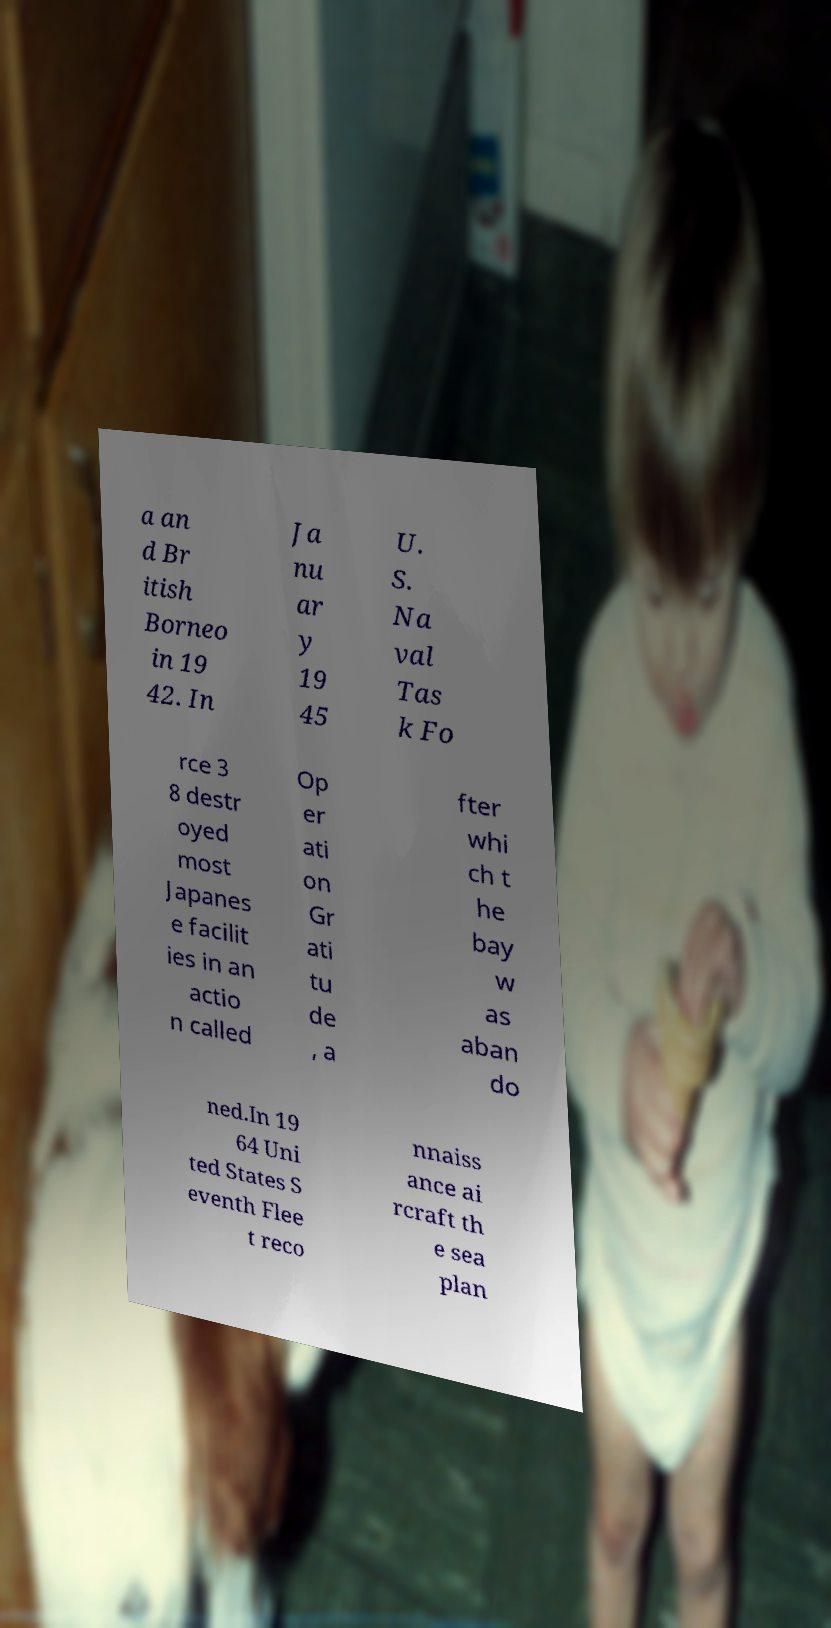Can you read and provide the text displayed in the image?This photo seems to have some interesting text. Can you extract and type it out for me? a an d Br itish Borneo in 19 42. In Ja nu ar y 19 45 U. S. Na val Tas k Fo rce 3 8 destr oyed most Japanes e facilit ies in an actio n called Op er ati on Gr ati tu de , a fter whi ch t he bay w as aban do ned.In 19 64 Uni ted States S eventh Flee t reco nnaiss ance ai rcraft th e sea plan 